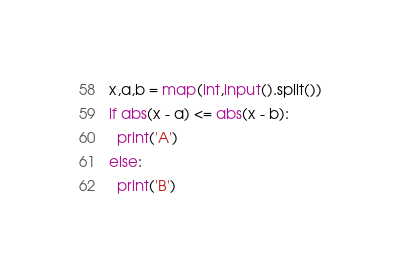<code> <loc_0><loc_0><loc_500><loc_500><_Python_>x,a,b = map(int,input().split())
if abs(x - a) <= abs(x - b):
  print('A')
else:
  print('B')</code> 